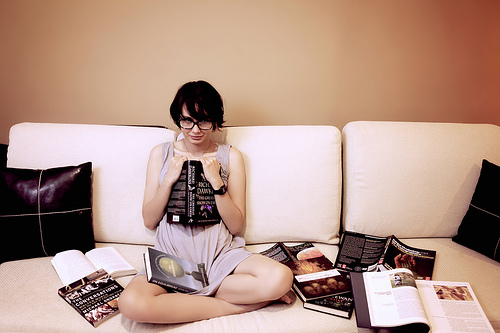<image>
Is there a pillow to the right of the woman? Yes. From this viewpoint, the pillow is positioned to the right side relative to the woman. Is the book in the couch? No. The book is not contained within the couch. These objects have a different spatial relationship. Is the book to the left of the woman? Yes. From this viewpoint, the book is positioned to the left side relative to the woman. Is the book in front of the woman? No. The book is not in front of the woman. The spatial positioning shows a different relationship between these objects. 